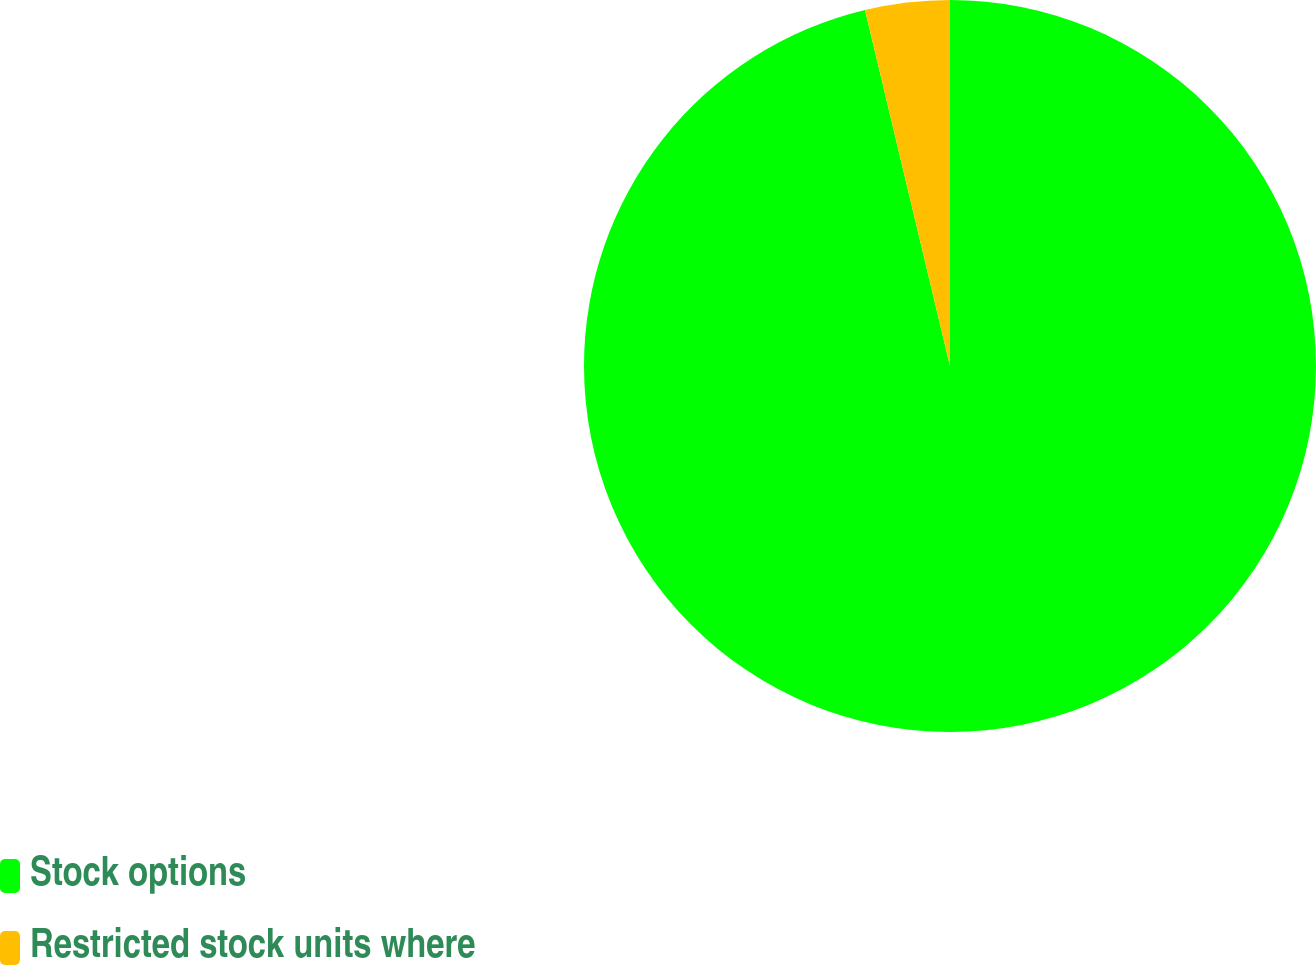Convert chart to OTSL. <chart><loc_0><loc_0><loc_500><loc_500><pie_chart><fcel>Stock options<fcel>Restricted stock units where<nl><fcel>96.27%<fcel>3.73%<nl></chart> 